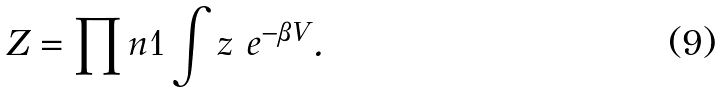<formula> <loc_0><loc_0><loc_500><loc_500>Z = \prod n { 1 } \int z \ e ^ { - \beta V } .</formula> 